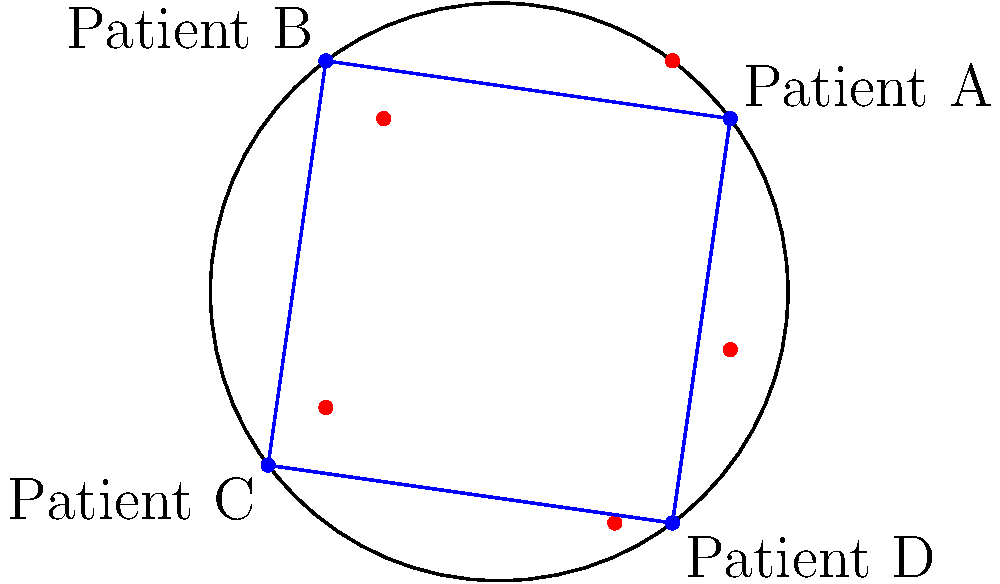In the hyperbolic plane model shown above, patient data points are represented by red dots, while four specific patients (A, B, C, and D) are connected by blue lines. Given that the distance between two points in hyperbolic geometry is calculated using the formula:

$$ d(p,q) = \text{arcosh}\left(1 + \frac{2|p-q|^2}{(1-|p|^2)(1-|q|^2)}\right) $$

Where $p$ and $q$ are the coordinates of two points, which pair of patients has the greatest hyperbolic distance between them? To solve this problem, we need to calculate the hyperbolic distance between each pair of patients and compare them. Let's go through the process step-by-step:

1. First, we need to identify the coordinates of each patient:
   Patient A: (4,3)
   Patient B: (-3,4)
   Patient C: (-4,-3)
   Patient D: (3,-4)

2. We'll calculate the hyperbolic distance for each pair using the given formula:

   $$ d(p,q) = \text{arcosh}\left(1 + \frac{2|p-q|^2}{(1-|p|^2)(1-|q|^2)}\right) $$

3. Let's calculate |p-q|^2 and (1-|p|^2)(1-|q|^2) for each pair:

   A-B: |p-q|^2 = (4-(-3))^2 + (3-4)^2 = 50
        (1-|p|^2)(1-|q|^2) = (1-25)(1-25) = 576
   
   A-C: |p-q|^2 = (4-(-4))^2 + (3-(-3))^2 = 100
        (1-|p|^2)(1-|q|^2) = (1-25)(1-25) = 576
   
   A-D: |p-q|^2 = (4-3)^2 + (3-(-4))^2 = 50
        (1-|p|^2)(1-|q|^2) = (1-25)(1-25) = 576
   
   B-C: |p-q|^2 = (-3-(-4))^2 + (4-(-3))^2 = 50
        (1-|p|^2)(1-|q|^2) = (1-25)(1-25) = 576
   
   B-D: |p-q|^2 = (-3-3)^2 + (4-(-4))^2 = 100
        (1-|p|^2)(1-|q|^2) = (1-25)(1-25) = 576
   
   C-D: |p-q|^2 = (-4-3)^2 + (-3-(-4))^2 = 50
        (1-|p|^2)(1-|q|^2) = (1-25)(1-25) = 576

4. Now, let's plug these values into the formula:

   d(A,B) = arcosh(1 + 2*50/576) ≈ 0.5878
   d(A,C) = arcosh(1 + 2*100/576) ≈ 0.8188
   d(A,D) = arcosh(1 + 2*50/576) ≈ 0.5878
   d(B,C) = arcosh(1 + 2*50/576) ≈ 0.5878
   d(B,D) = arcosh(1 + 2*100/576) ≈ 0.8188
   d(C,D) = arcosh(1 + 2*50/576) ≈ 0.5878

5. Comparing these distances, we can see that the greatest hyperbolic distance is between pairs A-C and B-D, both approximately 0.8188.
Answer: Patients A and C, or B and D 